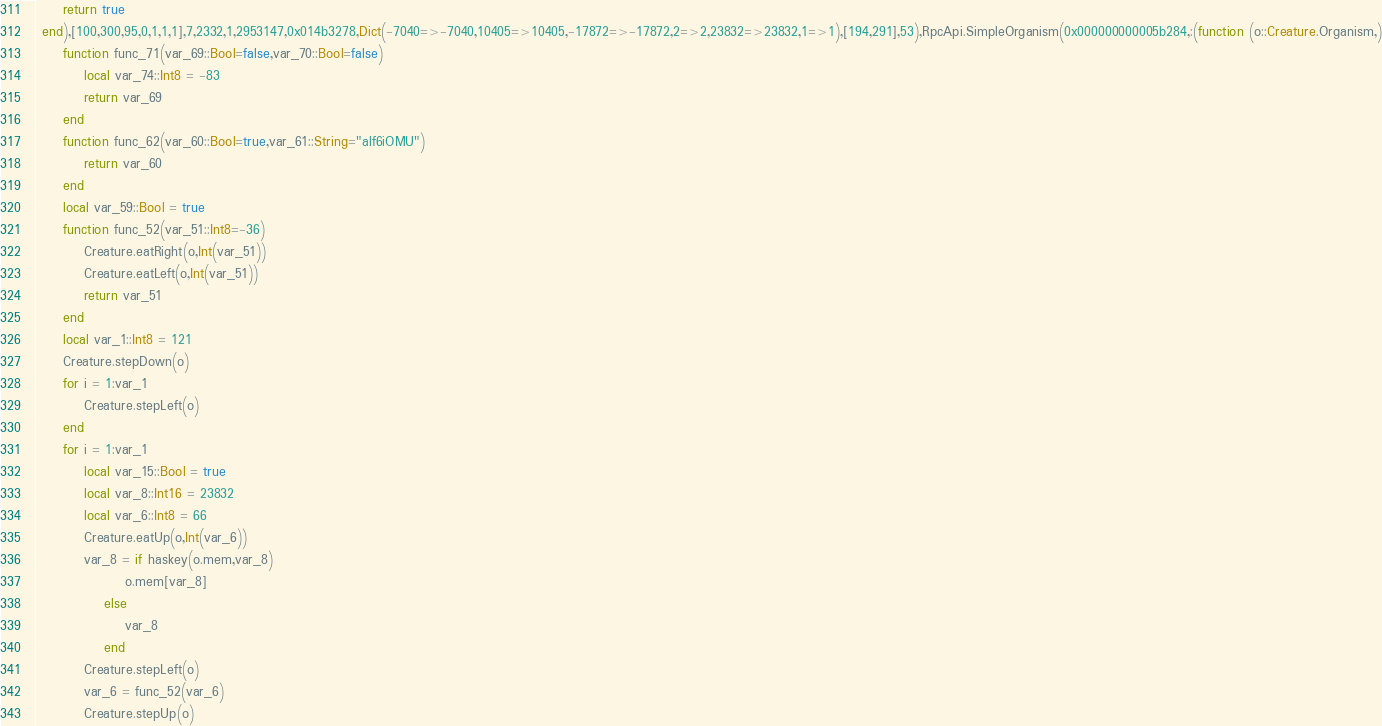<code> <loc_0><loc_0><loc_500><loc_500><_Julia_>     return true
 end),[100,300,95,0,1,1,1],7,2332,1,2953147,0x014b3278,Dict(-7040=>-7040,10405=>10405,-17872=>-17872,2=>2,23832=>23832,1=>1),[194,291],53),RpcApi.SimpleOrganism(0x000000000005b284,:(function (o::Creature.Organism,)
     function func_71(var_69::Bool=false,var_70::Bool=false)
         local var_74::Int8 = -83
         return var_69
     end
     function func_62(var_60::Bool=true,var_61::String="alf6iOMU")
         return var_60
     end
     local var_59::Bool = true
     function func_52(var_51::Int8=-36)
         Creature.eatRight(o,Int(var_51))
         Creature.eatLeft(o,Int(var_51))
         return var_51
     end
     local var_1::Int8 = 121
     Creature.stepDown(o)
     for i = 1:var_1
         Creature.stepLeft(o)
     end
     for i = 1:var_1
         local var_15::Bool = true
         local var_8::Int16 = 23832
         local var_6::Int8 = 66
         Creature.eatUp(o,Int(var_6))
         var_8 = if haskey(o.mem,var_8)
                 o.mem[var_8]
             else
                 var_8
             end
         Creature.stepLeft(o)
         var_6 = func_52(var_6)
         Creature.stepUp(o)</code> 